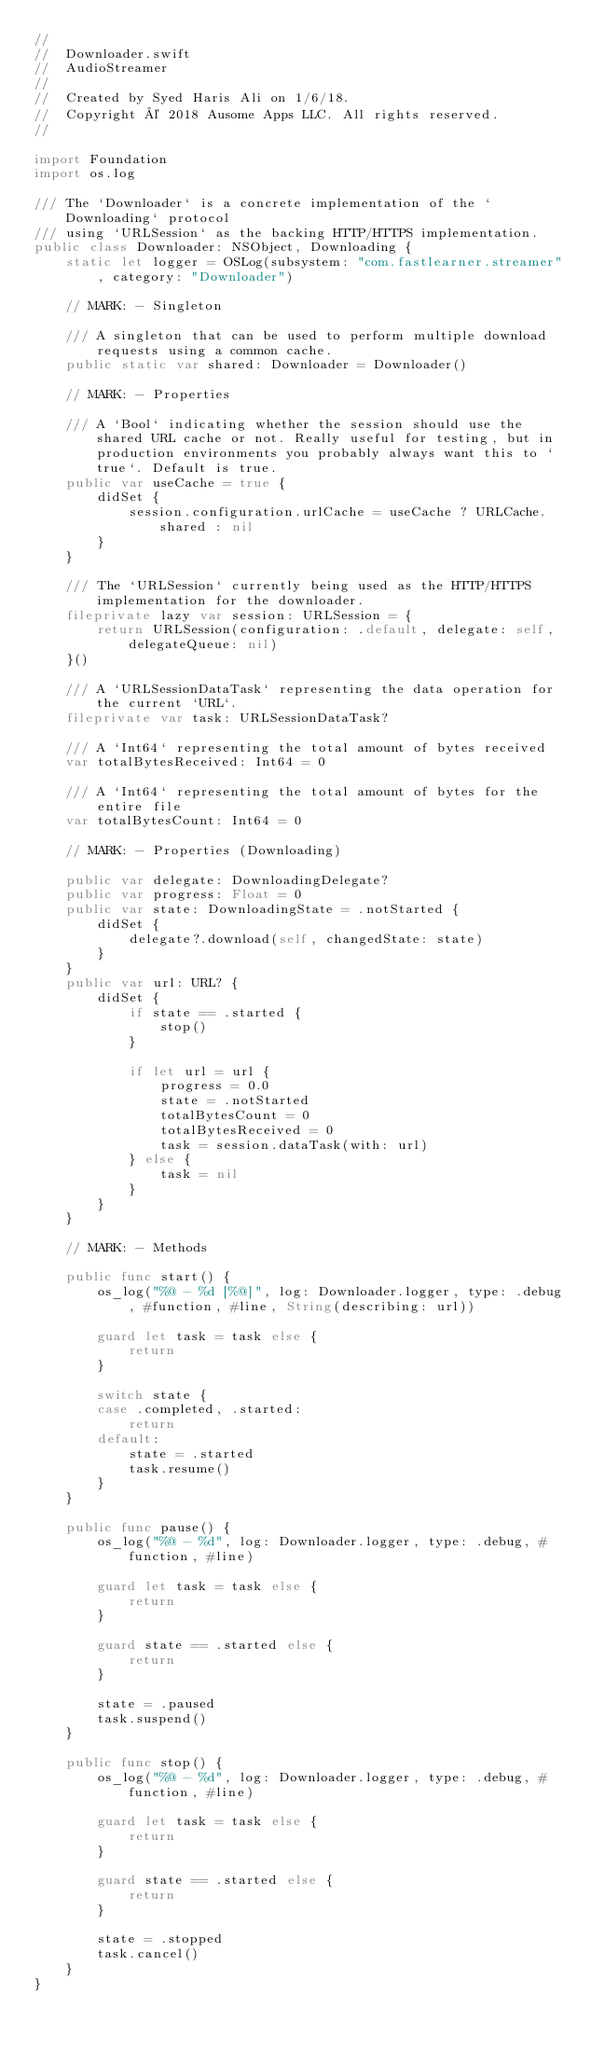<code> <loc_0><loc_0><loc_500><loc_500><_Swift_>//
//  Downloader.swift
//  AudioStreamer
//
//  Created by Syed Haris Ali on 1/6/18.
//  Copyright © 2018 Ausome Apps LLC. All rights reserved.
//

import Foundation
import os.log

/// The `Downloader` is a concrete implementation of the `Downloading` protocol
/// using `URLSession` as the backing HTTP/HTTPS implementation.
public class Downloader: NSObject, Downloading {
    static let logger = OSLog(subsystem: "com.fastlearner.streamer", category: "Downloader")
    
    // MARK: - Singleton
    
    /// A singleton that can be used to perform multiple download requests using a common cache.
    public static var shared: Downloader = Downloader()
    
    // MARK: - Properties
    
    /// A `Bool` indicating whether the session should use the shared URL cache or not. Really useful for testing, but in production environments you probably always want this to `true`. Default is true.
    public var useCache = true {
        didSet {
            session.configuration.urlCache = useCache ? URLCache.shared : nil
        }
    }
    
    /// The `URLSession` currently being used as the HTTP/HTTPS implementation for the downloader.
    fileprivate lazy var session: URLSession = {
        return URLSession(configuration: .default, delegate: self, delegateQueue: nil)
    }()
    
    /// A `URLSessionDataTask` representing the data operation for the current `URL`.
    fileprivate var task: URLSessionDataTask?
    
    /// A `Int64` representing the total amount of bytes received
    var totalBytesReceived: Int64 = 0
    
    /// A `Int64` representing the total amount of bytes for the entire file
    var totalBytesCount: Int64 = 0
    
    // MARK: - Properties (Downloading)
    
    public var delegate: DownloadingDelegate?
    public var progress: Float = 0
    public var state: DownloadingState = .notStarted {
        didSet {
            delegate?.download(self, changedState: state)
        }
    }
    public var url: URL? {
        didSet {
            if state == .started {
                stop()
            }
            
            if let url = url {
                progress = 0.0
                state = .notStarted
                totalBytesCount = 0
                totalBytesReceived = 0
                task = session.dataTask(with: url)
            } else {
                task = nil
            }
        }
    }
    
    // MARK: - Methods
    
    public func start() {
        os_log("%@ - %d [%@]", log: Downloader.logger, type: .debug, #function, #line, String(describing: url))
        
        guard let task = task else {
            return
        }
        
        switch state {
        case .completed, .started:
            return
        default:
            state = .started
            task.resume()
        }
    }
    
    public func pause() {
        os_log("%@ - %d", log: Downloader.logger, type: .debug, #function, #line)
        
        guard let task = task else {
            return
        }
        
        guard state == .started else {
            return
        }
        
        state = .paused
        task.suspend()
    }
    
    public func stop() {
        os_log("%@ - %d", log: Downloader.logger, type: .debug, #function, #line)
        
        guard let task = task else {
            return
        }
        
        guard state == .started else {
            return
        }
        
        state = .stopped
        task.cancel()
    }
}
</code> 